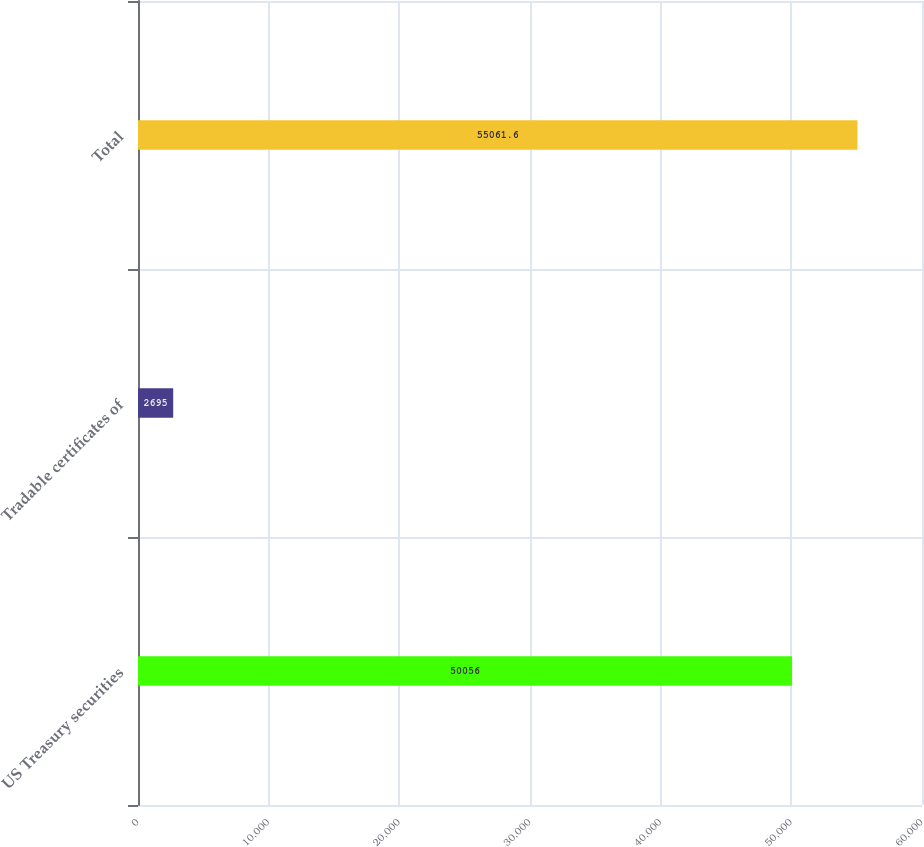Convert chart to OTSL. <chart><loc_0><loc_0><loc_500><loc_500><bar_chart><fcel>US Treasury securities<fcel>Tradable certificates of<fcel>Total<nl><fcel>50056<fcel>2695<fcel>55061.6<nl></chart> 